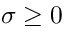Convert formula to latex. <formula><loc_0><loc_0><loc_500><loc_500>\sigma \geq 0</formula> 